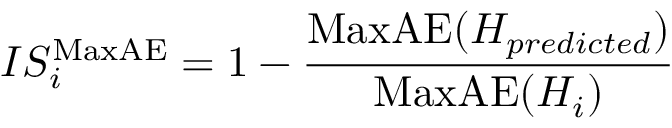<formula> <loc_0><loc_0><loc_500><loc_500>{ I S _ { i } ^ { M a x A E } = 1 - \frac { M a x A E ( H _ { p r e d i c t e d } ) } { M a x A E ( H _ { i } ) } }</formula> 